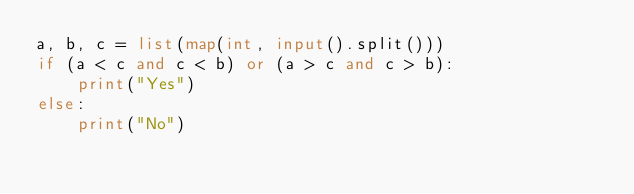<code> <loc_0><loc_0><loc_500><loc_500><_Python_>a, b, c = list(map(int, input().split()))
if (a < c and c < b) or (a > c and c > b):
    print("Yes")
else:
    print("No")
</code> 